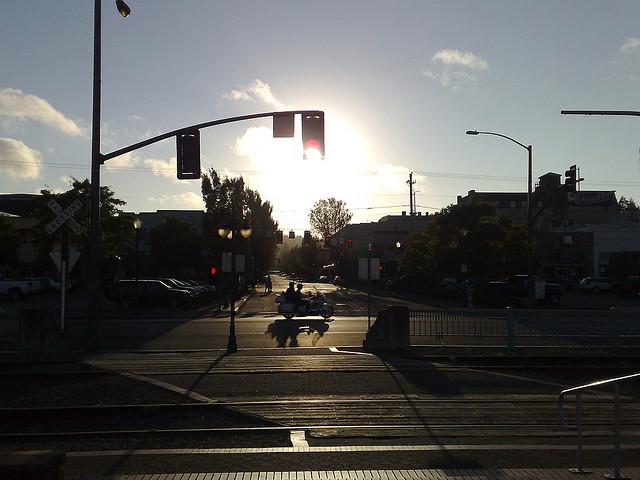What is lit up on each side of the street?
Write a very short answer. Traffic lights. What does the sign shaped like an x signify?
Write a very short answer. Railroad crossing. Where is the sun in this picture?
Be succinct. Going down. Are there parked cars?
Write a very short answer. Yes. What color is the traffic light?
Concise answer only. Red. 